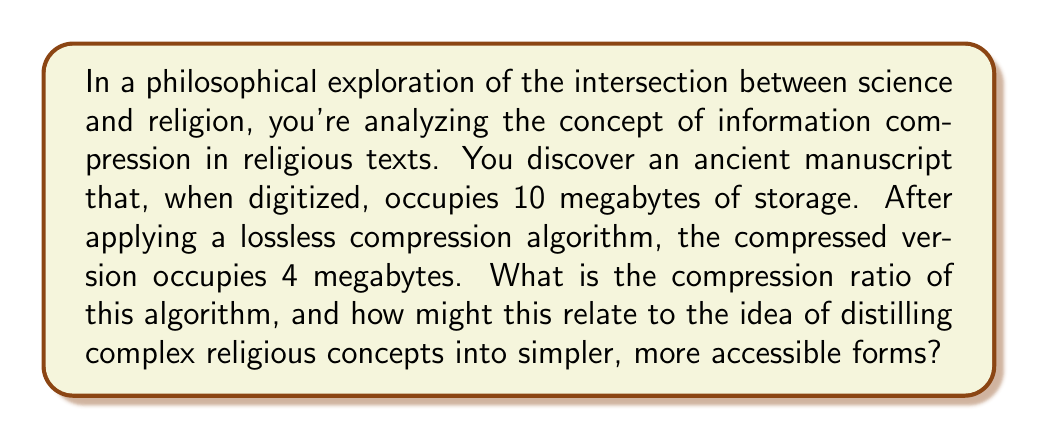Provide a solution to this math problem. To solve this problem, we need to understand the concept of compression ratio in information theory and apply it to the given scenario. The compression ratio is a measure of how much the data has been compressed relative to its original size.

The formula for compression ratio is:

$$ \text{Compression Ratio} = \frac{\text{Uncompressed Size}}{\text{Compressed Size}} $$

In this case:
- Uncompressed Size = 10 megabytes
- Compressed Size = 4 megabytes

Let's substitute these values into the formula:

$$ \text{Compression Ratio} = \frac{10 \text{ megabytes}}{4 \text{ megabytes}} = \frac{10}{4} = 2.5 $$

This means that the original data has been compressed to 1/2.5 of its original size, or equivalently, the compressed data takes up only 40% of the space of the original data.

To express this as a percentage of space saved, we can use the formula:

$$ \text{Space Saved (%)} = \left(1 - \frac{1}{\text{Compression Ratio}}\right) \times 100\% $$

$$ \text{Space Saved (%)} = \left(1 - \frac{1}{2.5}\right) \times 100\% = 60\% $$

In the context of the philosophical exploration of science and religion, this compression ratio could be interpreted as an analogy for how complex religious concepts might be distilled into simpler, more accessible forms. Just as the lossless compression algorithm reduces the size of the data without losing any information, religious teachings often attempt to convey profound truths through simpler parables, analogies, or rituals. The compression ratio of 2.5:1 suggests that it's possible to represent the same information more efficiently, which could be seen as parallel to the process of making abstract religious concepts more comprehensible to a wider audience.
Answer: The compression ratio is 2.5:1, or simply 2.5. This means the original data has been compressed to 40% of its original size, saving 60% of the storage space. 